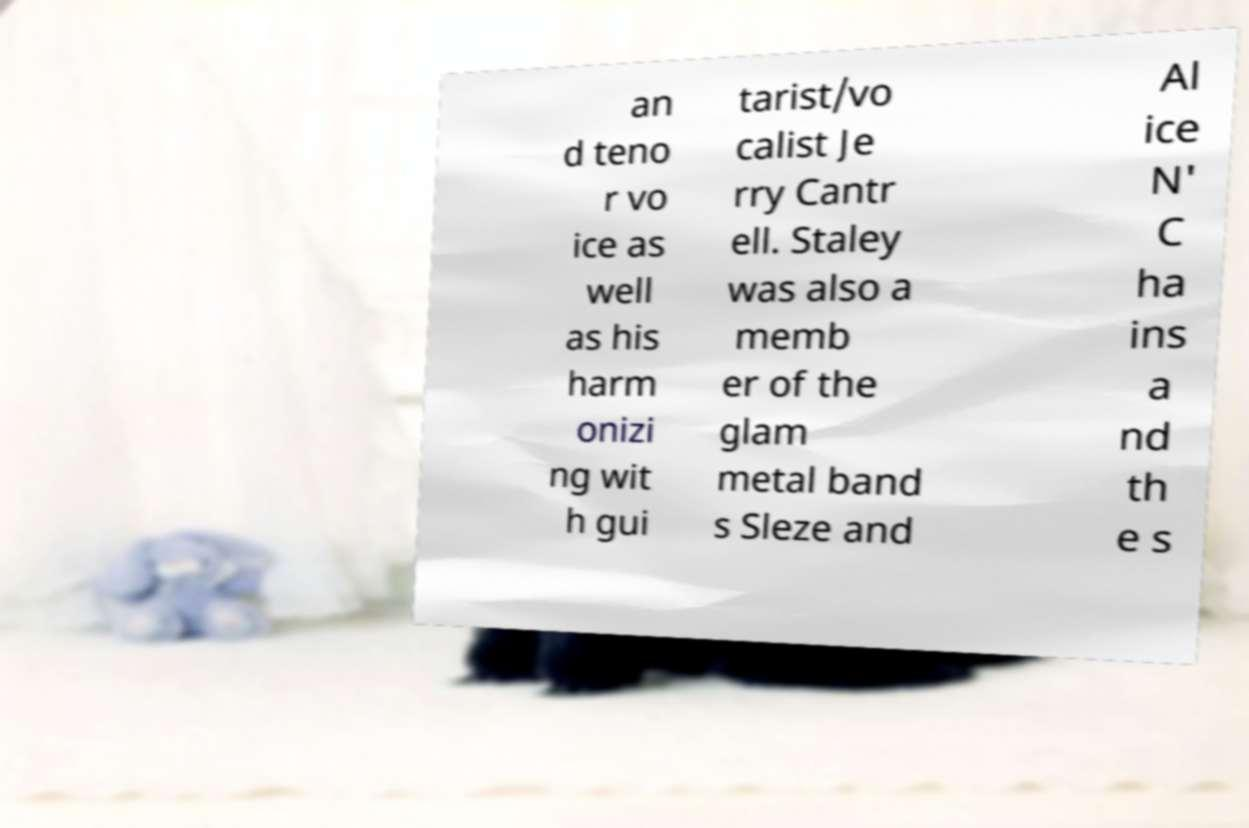Could you extract and type out the text from this image? an d teno r vo ice as well as his harm onizi ng wit h gui tarist/vo calist Je rry Cantr ell. Staley was also a memb er of the glam metal band s Sleze and Al ice N' C ha ins a nd th e s 